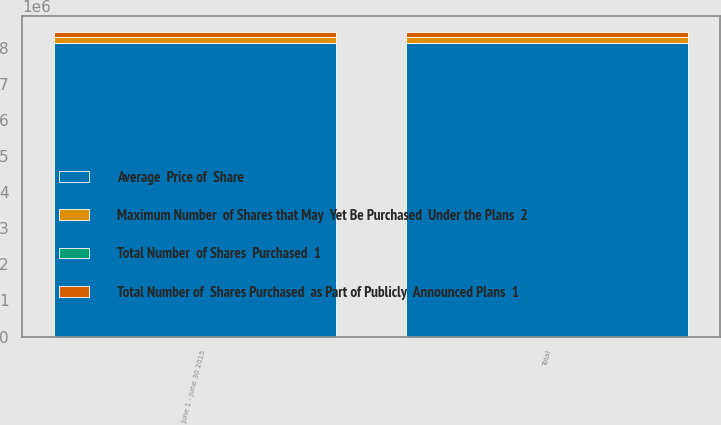<chart> <loc_0><loc_0><loc_500><loc_500><stacked_bar_chart><ecel><fcel>June 1 - June 30 2015<fcel>Total<nl><fcel>Maximum Number  of Shares that May  Yet Be Purchased  Under the Plans  2<fcel>150146<fcel>150146<nl><fcel>Total Number  of Shares  Purchased  1<fcel>65.87<fcel>65.87<nl><fcel>Total Number of  Shares Purchased  as Part of Publicly  Announced Plans  1<fcel>150100<fcel>150100<nl><fcel>Average  Price of  Share<fcel>8.14798e+06<fcel>8.14798e+06<nl></chart> 